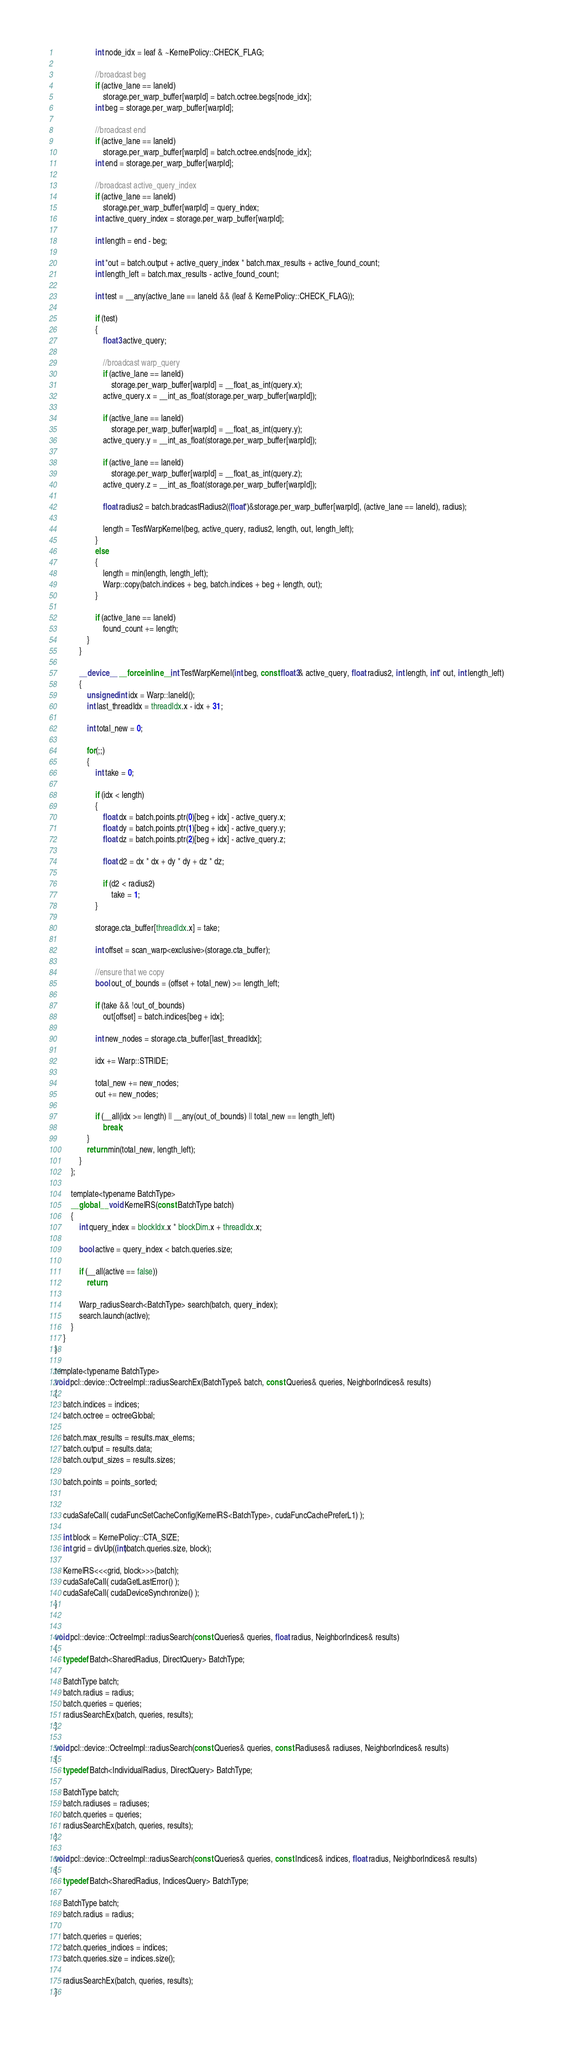<code> <loc_0><loc_0><loc_500><loc_500><_Cuda_>
                    int node_idx = leaf & ~KernelPolicy::CHECK_FLAG;

                    //broadcast beg
                    if (active_lane == laneId)
                        storage.per_warp_buffer[warpId] = batch.octree.begs[node_idx];                    
                    int beg = storage.per_warp_buffer[warpId];

                    //broadcast end
                    if (active_lane == laneId)
                        storage.per_warp_buffer[warpId] = batch.octree.ends[node_idx];
                    int end = storage.per_warp_buffer[warpId];

                    //broadcast active_query_index
                    if (active_lane == laneId)
                        storage.per_warp_buffer[warpId] = query_index;
                    int active_query_index = storage.per_warp_buffer[warpId];

                    int length = end - beg;

                    int *out = batch.output + active_query_index * batch.max_results + active_found_count;                    
                    int length_left = batch.max_results - active_found_count;

                    int test = __any(active_lane == laneId && (leaf & KernelPolicy::CHECK_FLAG));

                    if (test)
                    {                                        
                        float3 active_query;

                        //broadcast warp_query
                        if (active_lane == laneId)
                            storage.per_warp_buffer[warpId] = __float_as_int(query.x);
                        active_query.x = __int_as_float(storage.per_warp_buffer[warpId]);

                        if (active_lane == laneId)
                            storage.per_warp_buffer[warpId] = __float_as_int(query.y);
                        active_query.y = __int_as_float(storage.per_warp_buffer[warpId]);

                        if (active_lane == laneId)
                            storage.per_warp_buffer[warpId] = __float_as_int(query.z);
                        active_query.z = __int_as_float(storage.per_warp_buffer[warpId]);                            

                        float radius2 = batch.bradcastRadius2((float*)&storage.per_warp_buffer[warpId], (active_lane == laneId), radius);                            

                        length = TestWarpKernel(beg, active_query, radius2, length, out, length_left);                    
                    }
                    else
                    {                            
                        length = min(length, length_left);                        
                        Warp::copy(batch.indices + beg, batch.indices + beg + length, out);
                    }

                    if (active_lane == laneId)
                        found_count += length;
                }            
            }    

            __device__ __forceinline__ int TestWarpKernel(int beg, const float3& active_query, float radius2, int length, int* out, int length_left)
            {                        
                unsigned int idx = Warp::laneId();
                int last_threadIdx = threadIdx.x - idx + 31;            

                int total_new = 0;

                for(;;)
                {                
                    int take = 0;

                    if (idx < length)
                    {                                                                                                            
                        float dx = batch.points.ptr(0)[beg + idx] - active_query.x;
                        float dy = batch.points.ptr(1)[beg + idx] - active_query.y;
                        float dz = batch.points.ptr(2)[beg + idx] - active_query.z;

                        float d2 = dx * dx + dy * dy + dz * dz;

                        if (d2 < radius2)
                            take = 1;
                    }

                    storage.cta_buffer[threadIdx.x] = take;

                    int offset = scan_warp<exclusive>(storage.cta_buffer);

                    //ensure that we copy
                    bool out_of_bounds = (offset + total_new) >= length_left;                              

                    if (take && !out_of_bounds)
                        out[offset] = batch.indices[beg + idx];

                    int new_nodes = storage.cta_buffer[last_threadIdx];

                    idx += Warp::STRIDE;

                    total_new += new_nodes;
                    out += new_nodes;                

                    if (__all(idx >= length) || __any(out_of_bounds) || total_new == length_left)
                        break;
                }
                return min(total_new, length_left);
            }
        };

        template<typename BatchType>
        __global__ void KernelRS(const BatchType batch) 
        {         
            int query_index = blockIdx.x * blockDim.x + threadIdx.x;

            bool active = query_index < batch.queries.size;

            if (__all(active == false)) 
                return;

            Warp_radiusSearch<BatchType> search(batch, query_index);
            search.launch(active); 
        }
    }
}

template<typename BatchType>
void pcl::device::OctreeImpl::radiusSearchEx(BatchType& batch, const Queries& queries, NeighborIndices& results)
{
    batch.indices = indices;
    batch.octree = octreeGlobal;

    batch.max_results = results.max_elems;
    batch.output = results.data;                
    batch.output_sizes = results.sizes;

    batch.points = points_sorted;
    
    
    cudaSafeCall( cudaFuncSetCacheConfig(KernelRS<BatchType>, cudaFuncCachePreferL1) );

    int block = KernelPolicy::CTA_SIZE;
    int grid = divUp((int)batch.queries.size, block);

    KernelRS<<<grid, block>>>(batch);
    cudaSafeCall( cudaGetLastError() );
    cudaSafeCall( cudaDeviceSynchronize() );
}


void pcl::device::OctreeImpl::radiusSearch(const Queries& queries, float radius, NeighborIndices& results)
{        
    typedef Batch<SharedRadius, DirectQuery> BatchType;

    BatchType batch;
    batch.radius = radius;
    batch.queries = queries;
    radiusSearchEx(batch, queries, results);              
}

void pcl::device::OctreeImpl::radiusSearch(const Queries& queries, const Radiuses& radiuses, NeighborIndices& results)
{
    typedef Batch<IndividualRadius, DirectQuery> BatchType;

    BatchType batch;
    batch.radiuses = radiuses;
    batch.queries = queries;
    radiusSearchEx(batch, queries, results);              
}

void pcl::device::OctreeImpl::radiusSearch(const Queries& queries, const Indices& indices, float radius, NeighborIndices& results)
{
    typedef Batch<SharedRadius, IndicesQuery> BatchType;

    BatchType batch;
    batch.radius = radius;
    
    batch.queries = queries;
    batch.queries_indices = indices;
    batch.queries.size = indices.size();

    radiusSearchEx(batch, queries, results);        
}
</code> 